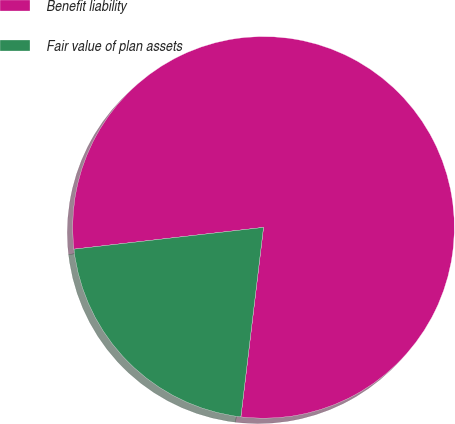Convert chart. <chart><loc_0><loc_0><loc_500><loc_500><pie_chart><fcel>Benefit liability<fcel>Fair value of plan assets<nl><fcel>78.71%<fcel>21.29%<nl></chart> 